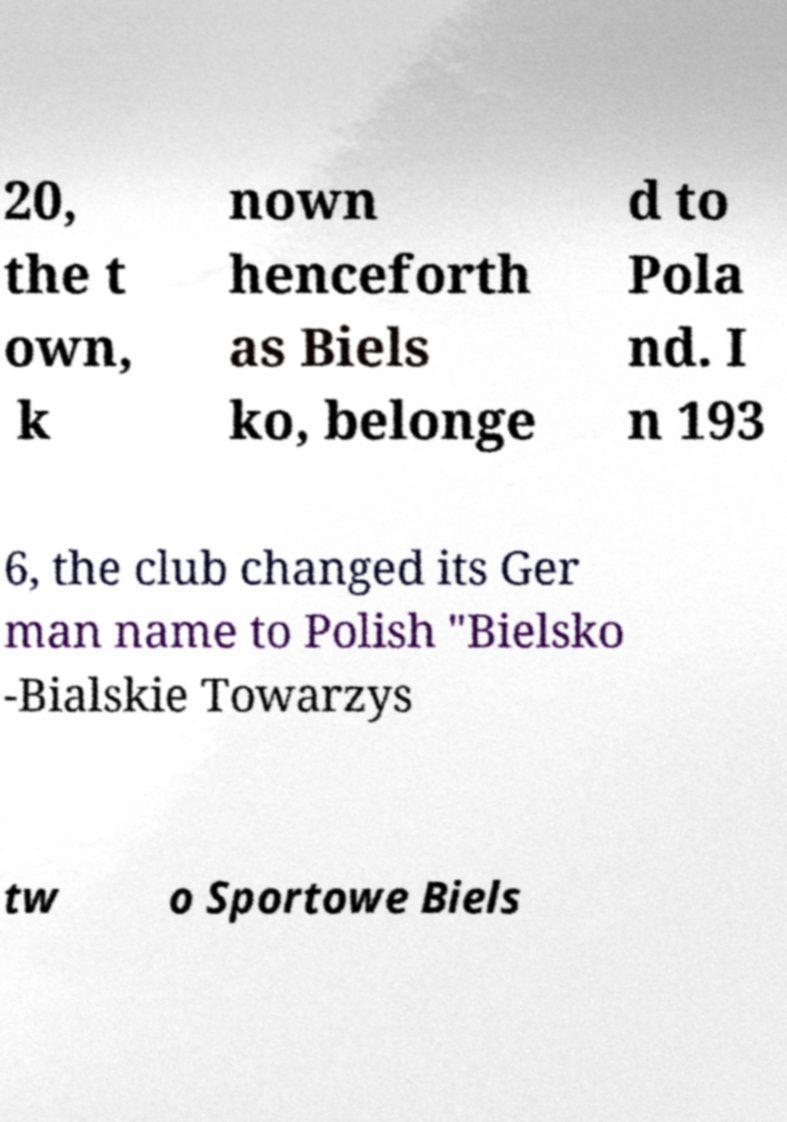There's text embedded in this image that I need extracted. Can you transcribe it verbatim? 20, the t own, k nown henceforth as Biels ko, belonge d to Pola nd. I n 193 6, the club changed its Ger man name to Polish "Bielsko -Bialskie Towarzys tw o Sportowe Biels 